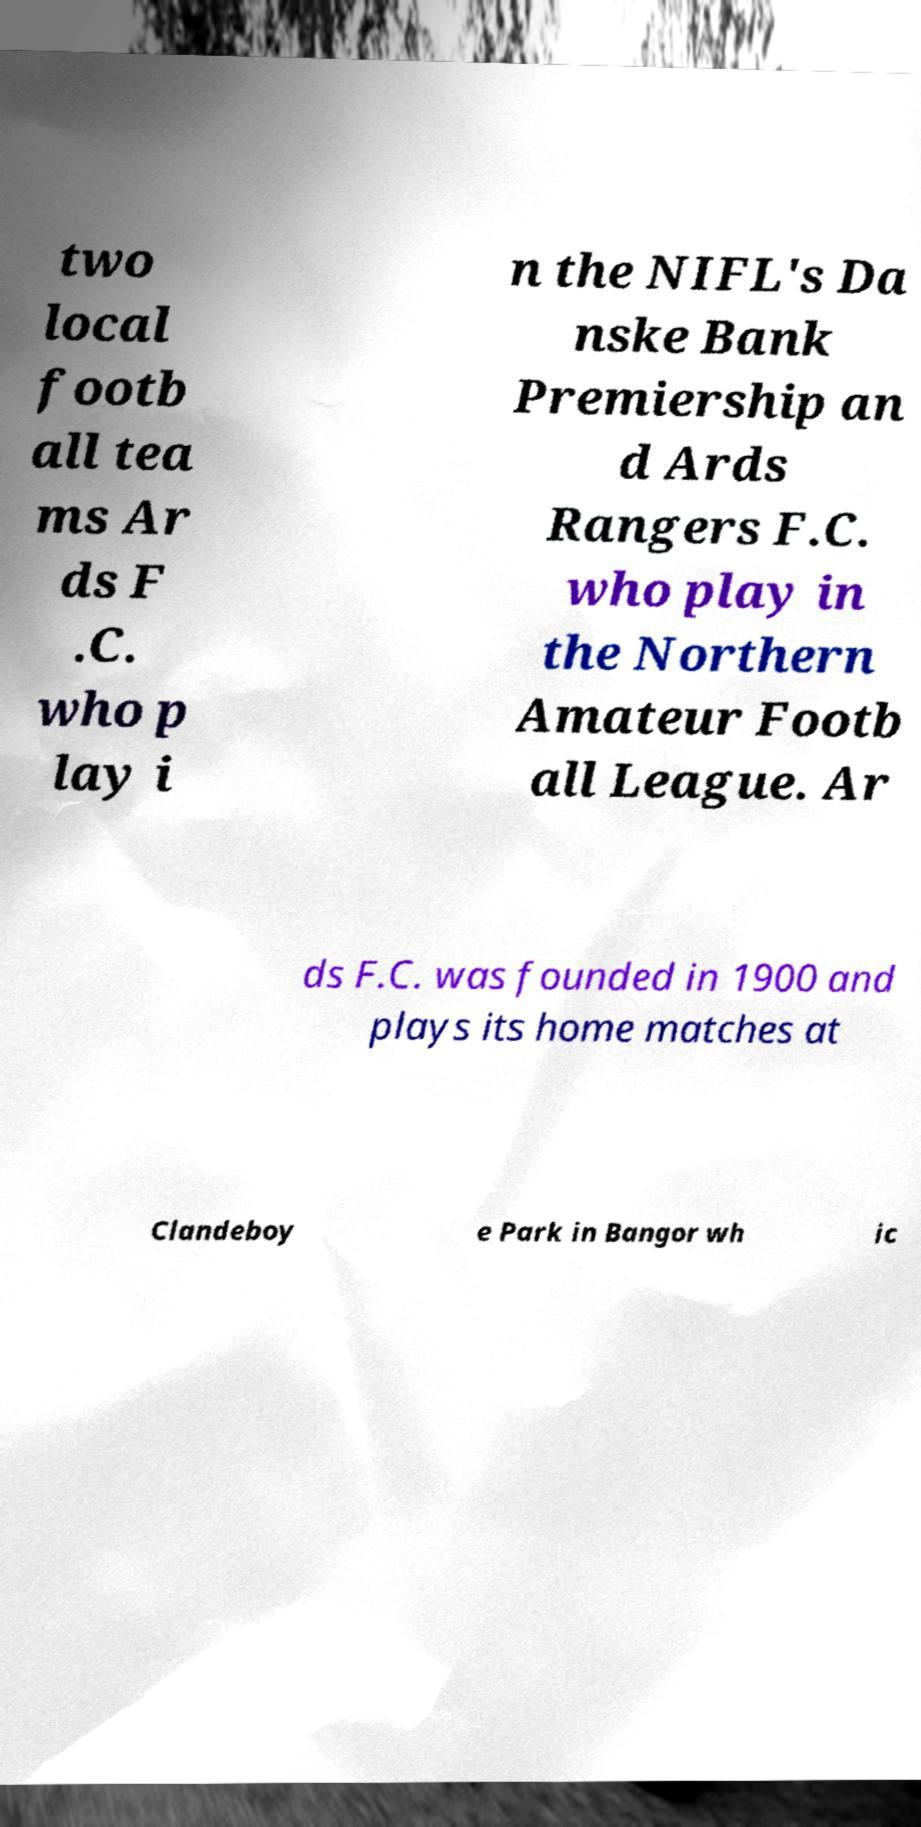For documentation purposes, I need the text within this image transcribed. Could you provide that? two local footb all tea ms Ar ds F .C. who p lay i n the NIFL's Da nske Bank Premiership an d Ards Rangers F.C. who play in the Northern Amateur Footb all League. Ar ds F.C. was founded in 1900 and plays its home matches at Clandeboy e Park in Bangor wh ic 